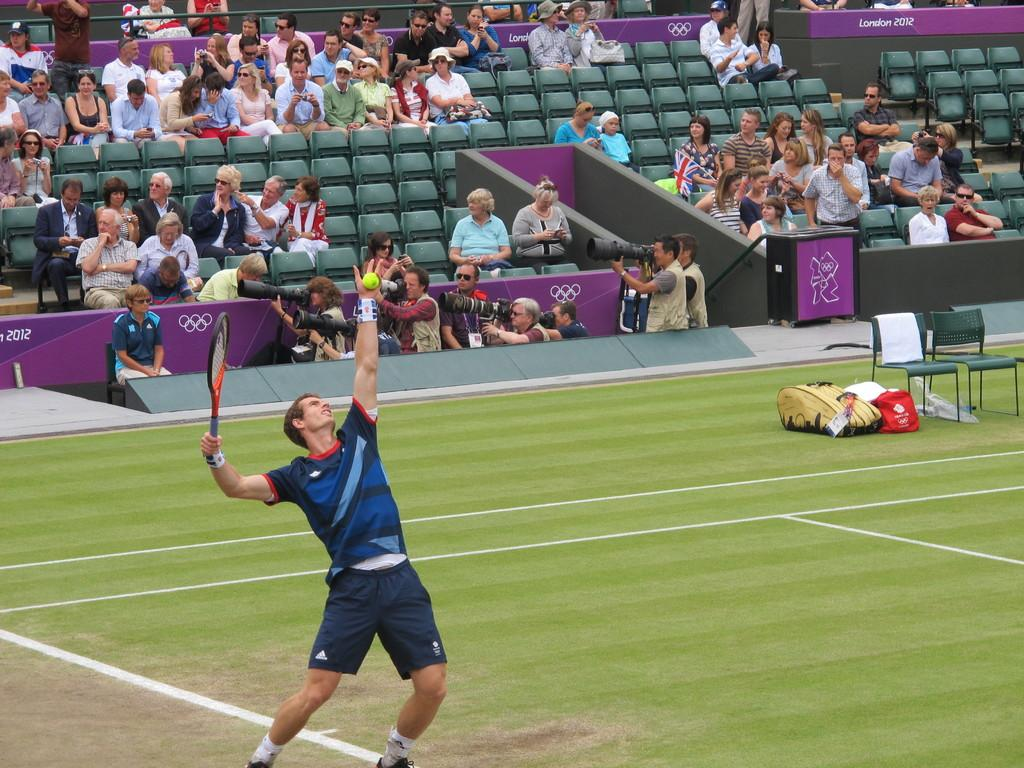<image>
Present a compact description of the photo's key features. A man prepares to serve a tennis ball at the London 2012 Olympics. 